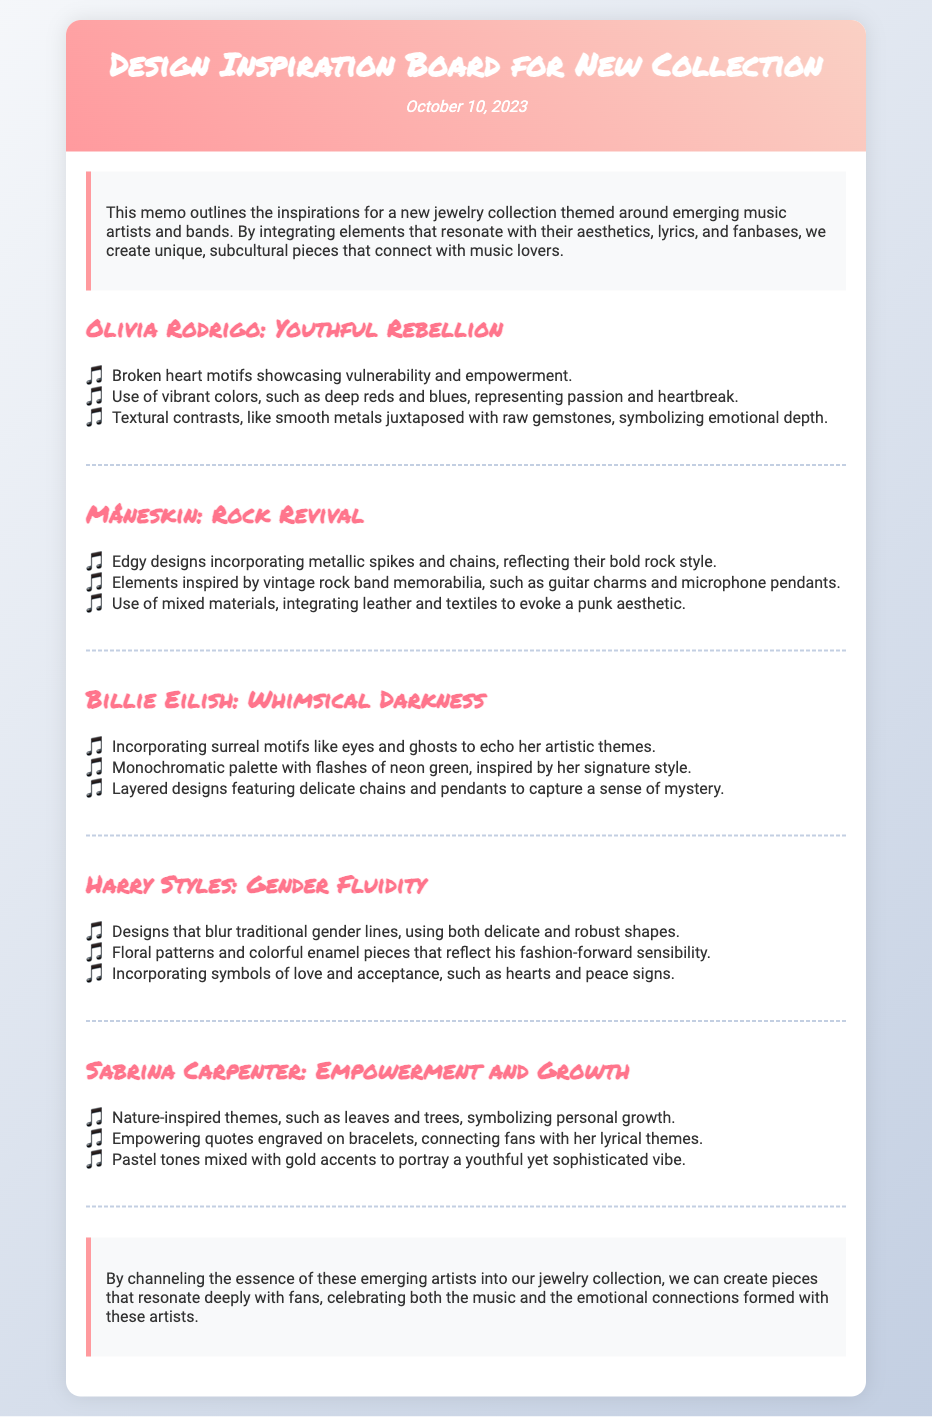What is the date of the memo? The date stated at the top of the memo indicates when it was created, which is noted as October 10, 2023.
Answer: October 10, 2023 Who is the first artist mentioned in the document? The memo lists various artists, starting with Olivia Rodrigo as the first artist in the artist sections.
Answer: Olivia Rodrigo What motif is used to represent vulnerability in Olivia Rodrigo's section? The memo specifies that broken heart motifs symbolize vulnerability and empowerment, which are elements driven by Olivia Rodrigo's themes.
Answer: Broken heart motifs What color palette is associated with Billie Eilish? The document describes Billie Eilish's section mentioning a monochromatic palette with flashes of a specific bright color, which is noted as neon green.
Answer: Monochromatic palette with flashes of neon green Which artist's designs blur traditional gender lines? The memo illustrates Harry Styles' approach, noting that his designs merge traditional gender lines through unique shapes and patterns.
Answer: Harry Styles How many artist sections are there in the document? The memo includes a clear breakdown, with a total of five distinct artist sections represented throughout the content.
Answer: Five What type of quotes are found in Sabrina Carpenter's section? The memo notes that empowering quotes engraved on bracelets are a key aspect of Sabrina Carpenter's themes, connecting fans to her lyrics.
Answer: Empowering quotes What permanent theme connects the emerging artists discussed in the memo? The document concludes by emphasizing that the essence of the artists fosters connections with fans through the emotional and aesthetic qualities of the pieces.
Answer: Emotional connections What overall theme is this collection based on? The memo outlines that the overarching theme of the new jewelry collection centers around emerging music artists and bands.
Answer: Emerging music artists and bands 